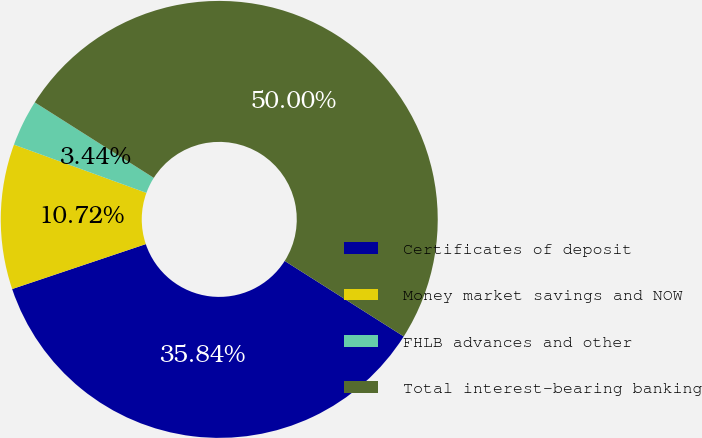Convert chart to OTSL. <chart><loc_0><loc_0><loc_500><loc_500><pie_chart><fcel>Certificates of deposit<fcel>Money market savings and NOW<fcel>FHLB advances and other<fcel>Total interest-bearing banking<nl><fcel>35.84%<fcel>10.72%<fcel>3.44%<fcel>50.0%<nl></chart> 